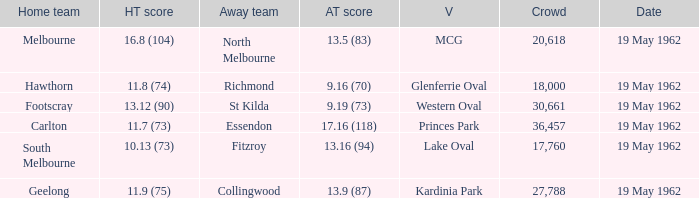8 (104)? 13.5 (83). 